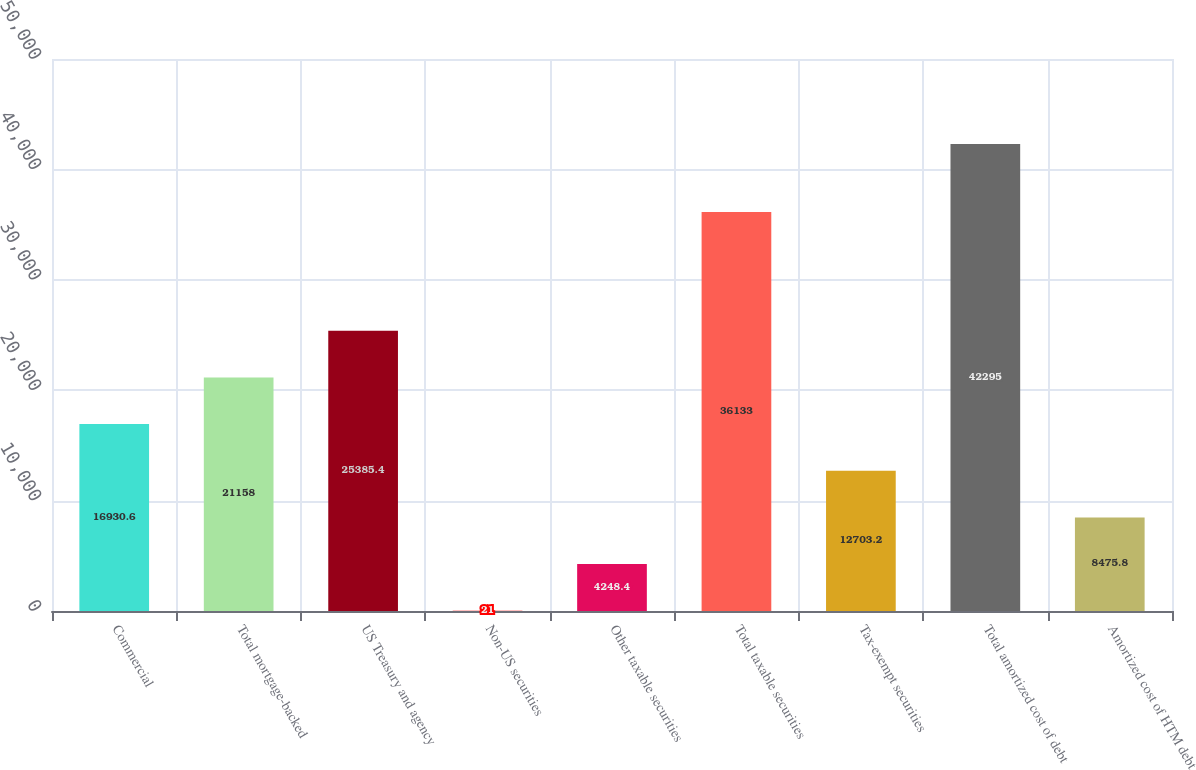<chart> <loc_0><loc_0><loc_500><loc_500><bar_chart><fcel>Commercial<fcel>Total mortgage-backed<fcel>US Treasury and agency<fcel>Non-US securities<fcel>Other taxable securities<fcel>Total taxable securities<fcel>Tax-exempt securities<fcel>Total amortized cost of debt<fcel>Amortized cost of HTM debt<nl><fcel>16930.6<fcel>21158<fcel>25385.4<fcel>21<fcel>4248.4<fcel>36133<fcel>12703.2<fcel>42295<fcel>8475.8<nl></chart> 